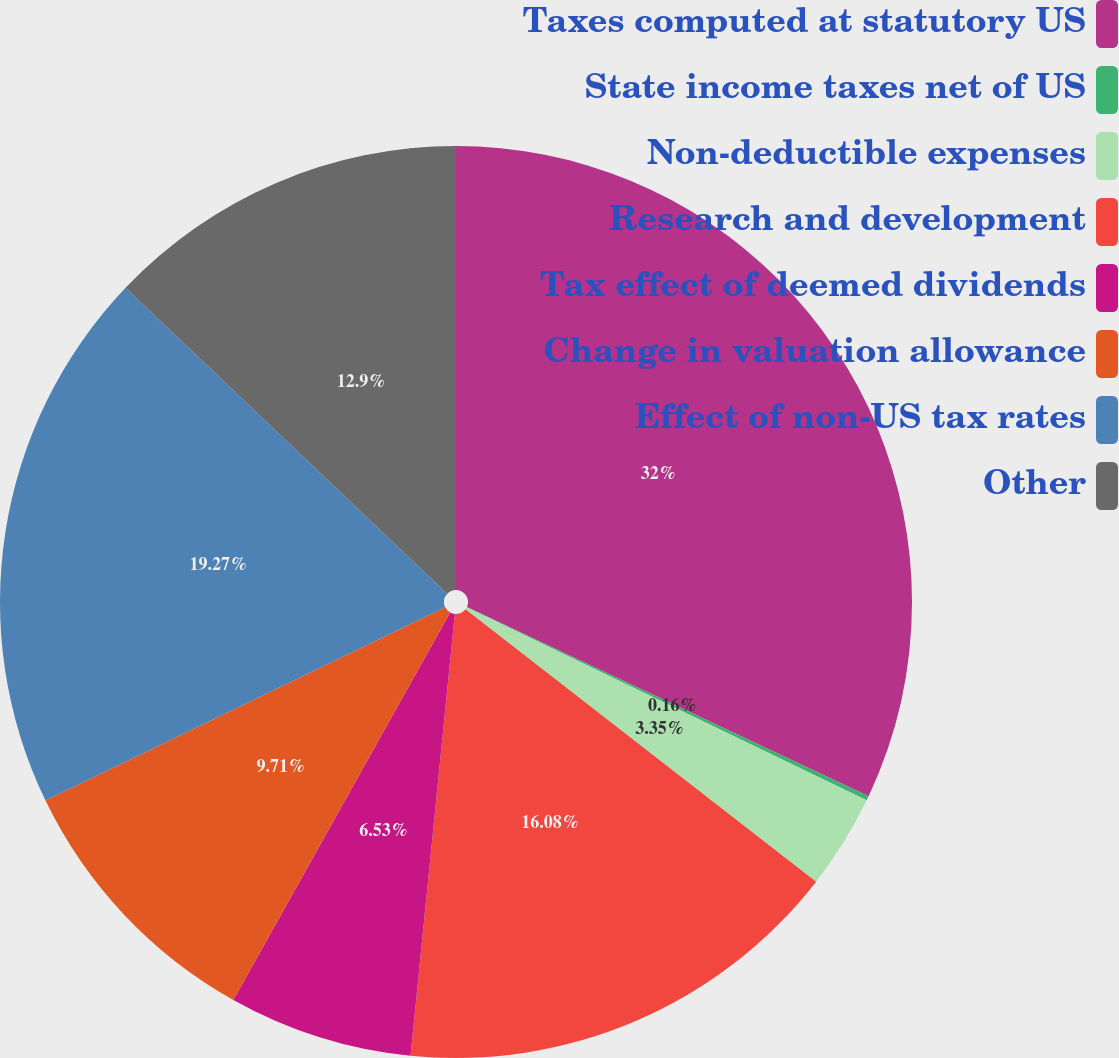<chart> <loc_0><loc_0><loc_500><loc_500><pie_chart><fcel>Taxes computed at statutory US<fcel>State income taxes net of US<fcel>Non-deductible expenses<fcel>Research and development<fcel>Tax effect of deemed dividends<fcel>Change in valuation allowance<fcel>Effect of non-US tax rates<fcel>Other<nl><fcel>32.0%<fcel>0.16%<fcel>3.35%<fcel>16.08%<fcel>6.53%<fcel>9.71%<fcel>19.27%<fcel>12.9%<nl></chart> 